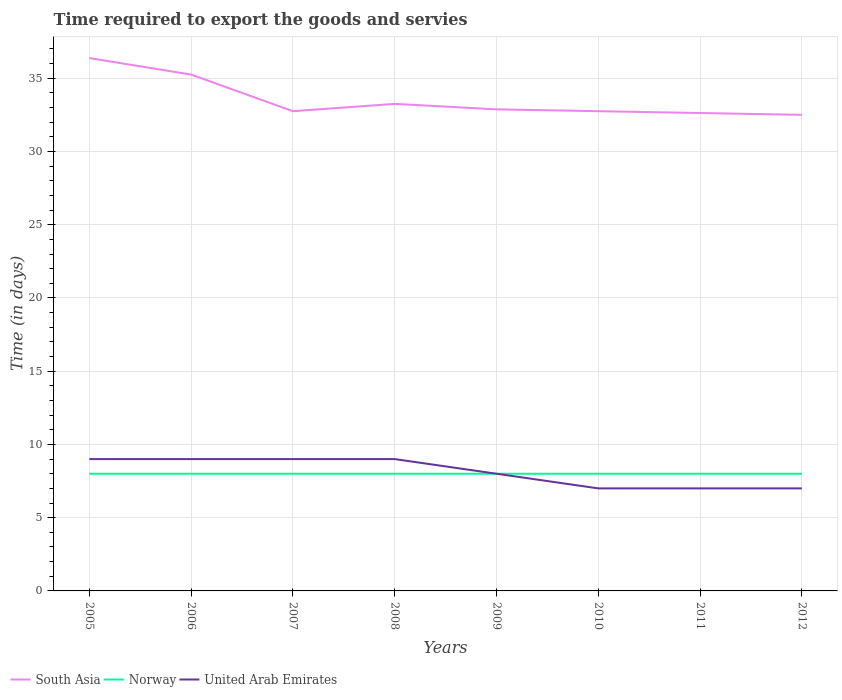How many different coloured lines are there?
Keep it short and to the point. 3. Does the line corresponding to United Arab Emirates intersect with the line corresponding to Norway?
Your response must be concise. Yes. Across all years, what is the maximum number of days required to export the goods and services in Norway?
Your answer should be compact. 8. In which year was the number of days required to export the goods and services in Norway maximum?
Give a very brief answer. 2005. What is the total number of days required to export the goods and services in United Arab Emirates in the graph?
Your answer should be compact. 2. What is the difference between the highest and the lowest number of days required to export the goods and services in Norway?
Your answer should be very brief. 0. Is the number of days required to export the goods and services in Norway strictly greater than the number of days required to export the goods and services in South Asia over the years?
Offer a very short reply. Yes. How many lines are there?
Provide a succinct answer. 3. How many years are there in the graph?
Provide a succinct answer. 8. Where does the legend appear in the graph?
Your response must be concise. Bottom left. How many legend labels are there?
Ensure brevity in your answer.  3. How are the legend labels stacked?
Give a very brief answer. Horizontal. What is the title of the graph?
Offer a terse response. Time required to export the goods and servies. Does "Malawi" appear as one of the legend labels in the graph?
Offer a very short reply. No. What is the label or title of the Y-axis?
Your answer should be compact. Time (in days). What is the Time (in days) of South Asia in 2005?
Ensure brevity in your answer.  36.38. What is the Time (in days) of Norway in 2005?
Keep it short and to the point. 8. What is the Time (in days) in South Asia in 2006?
Keep it short and to the point. 35.25. What is the Time (in days) in Norway in 2006?
Make the answer very short. 8. What is the Time (in days) of United Arab Emirates in 2006?
Ensure brevity in your answer.  9. What is the Time (in days) in South Asia in 2007?
Your response must be concise. 32.75. What is the Time (in days) in Norway in 2007?
Ensure brevity in your answer.  8. What is the Time (in days) of United Arab Emirates in 2007?
Your response must be concise. 9. What is the Time (in days) of South Asia in 2008?
Make the answer very short. 33.25. What is the Time (in days) of United Arab Emirates in 2008?
Offer a terse response. 9. What is the Time (in days) in South Asia in 2009?
Your response must be concise. 32.88. What is the Time (in days) in United Arab Emirates in 2009?
Your answer should be very brief. 8. What is the Time (in days) in South Asia in 2010?
Provide a succinct answer. 32.75. What is the Time (in days) in United Arab Emirates in 2010?
Offer a terse response. 7. What is the Time (in days) of South Asia in 2011?
Provide a succinct answer. 32.62. What is the Time (in days) in Norway in 2011?
Offer a very short reply. 8. What is the Time (in days) in United Arab Emirates in 2011?
Keep it short and to the point. 7. What is the Time (in days) in South Asia in 2012?
Offer a very short reply. 32.5. What is the Time (in days) in Norway in 2012?
Give a very brief answer. 8. What is the Time (in days) of United Arab Emirates in 2012?
Your response must be concise. 7. Across all years, what is the maximum Time (in days) of South Asia?
Keep it short and to the point. 36.38. Across all years, what is the minimum Time (in days) in South Asia?
Make the answer very short. 32.5. Across all years, what is the minimum Time (in days) in Norway?
Provide a short and direct response. 8. What is the total Time (in days) of South Asia in the graph?
Provide a short and direct response. 268.38. What is the total Time (in days) of Norway in the graph?
Your response must be concise. 64. What is the total Time (in days) of United Arab Emirates in the graph?
Your answer should be very brief. 65. What is the difference between the Time (in days) of South Asia in 2005 and that in 2007?
Provide a succinct answer. 3.62. What is the difference between the Time (in days) of Norway in 2005 and that in 2007?
Make the answer very short. 0. What is the difference between the Time (in days) of South Asia in 2005 and that in 2008?
Make the answer very short. 3.12. What is the difference between the Time (in days) of Norway in 2005 and that in 2008?
Make the answer very short. 0. What is the difference between the Time (in days) of South Asia in 2005 and that in 2009?
Offer a very short reply. 3.5. What is the difference between the Time (in days) in United Arab Emirates in 2005 and that in 2009?
Your answer should be very brief. 1. What is the difference between the Time (in days) of South Asia in 2005 and that in 2010?
Your answer should be very brief. 3.62. What is the difference between the Time (in days) of United Arab Emirates in 2005 and that in 2010?
Your answer should be very brief. 2. What is the difference between the Time (in days) of South Asia in 2005 and that in 2011?
Your answer should be very brief. 3.75. What is the difference between the Time (in days) of Norway in 2005 and that in 2011?
Ensure brevity in your answer.  0. What is the difference between the Time (in days) of South Asia in 2005 and that in 2012?
Provide a succinct answer. 3.88. What is the difference between the Time (in days) of Norway in 2005 and that in 2012?
Give a very brief answer. 0. What is the difference between the Time (in days) in United Arab Emirates in 2005 and that in 2012?
Your answer should be very brief. 2. What is the difference between the Time (in days) in Norway in 2006 and that in 2007?
Offer a very short reply. 0. What is the difference between the Time (in days) in United Arab Emirates in 2006 and that in 2007?
Provide a succinct answer. 0. What is the difference between the Time (in days) in United Arab Emirates in 2006 and that in 2008?
Offer a terse response. 0. What is the difference between the Time (in days) in South Asia in 2006 and that in 2009?
Provide a succinct answer. 2.38. What is the difference between the Time (in days) of Norway in 2006 and that in 2009?
Ensure brevity in your answer.  0. What is the difference between the Time (in days) in South Asia in 2006 and that in 2010?
Make the answer very short. 2.5. What is the difference between the Time (in days) in Norway in 2006 and that in 2010?
Provide a succinct answer. 0. What is the difference between the Time (in days) of South Asia in 2006 and that in 2011?
Keep it short and to the point. 2.62. What is the difference between the Time (in days) in Norway in 2006 and that in 2011?
Your answer should be very brief. 0. What is the difference between the Time (in days) of South Asia in 2006 and that in 2012?
Your answer should be compact. 2.75. What is the difference between the Time (in days) of United Arab Emirates in 2006 and that in 2012?
Give a very brief answer. 2. What is the difference between the Time (in days) in South Asia in 2007 and that in 2008?
Your response must be concise. -0.5. What is the difference between the Time (in days) in Norway in 2007 and that in 2008?
Keep it short and to the point. 0. What is the difference between the Time (in days) of United Arab Emirates in 2007 and that in 2008?
Offer a terse response. 0. What is the difference between the Time (in days) in South Asia in 2007 and that in 2009?
Ensure brevity in your answer.  -0.12. What is the difference between the Time (in days) in United Arab Emirates in 2007 and that in 2010?
Your answer should be compact. 2. What is the difference between the Time (in days) in South Asia in 2007 and that in 2011?
Keep it short and to the point. 0.12. What is the difference between the Time (in days) of South Asia in 2007 and that in 2012?
Offer a very short reply. 0.25. What is the difference between the Time (in days) of United Arab Emirates in 2007 and that in 2012?
Your answer should be very brief. 2. What is the difference between the Time (in days) in United Arab Emirates in 2008 and that in 2009?
Make the answer very short. 1. What is the difference between the Time (in days) of United Arab Emirates in 2008 and that in 2010?
Provide a short and direct response. 2. What is the difference between the Time (in days) in South Asia in 2008 and that in 2012?
Ensure brevity in your answer.  0.75. What is the difference between the Time (in days) in South Asia in 2009 and that in 2011?
Your answer should be very brief. 0.25. What is the difference between the Time (in days) of Norway in 2009 and that in 2011?
Offer a very short reply. 0. What is the difference between the Time (in days) of United Arab Emirates in 2009 and that in 2011?
Your answer should be compact. 1. What is the difference between the Time (in days) of Norway in 2009 and that in 2012?
Provide a succinct answer. 0. What is the difference between the Time (in days) in Norway in 2010 and that in 2011?
Provide a short and direct response. 0. What is the difference between the Time (in days) in United Arab Emirates in 2010 and that in 2011?
Your response must be concise. 0. What is the difference between the Time (in days) in South Asia in 2010 and that in 2012?
Offer a very short reply. 0.25. What is the difference between the Time (in days) in Norway in 2010 and that in 2012?
Keep it short and to the point. 0. What is the difference between the Time (in days) of South Asia in 2011 and that in 2012?
Offer a terse response. 0.12. What is the difference between the Time (in days) in Norway in 2011 and that in 2012?
Ensure brevity in your answer.  0. What is the difference between the Time (in days) in South Asia in 2005 and the Time (in days) in Norway in 2006?
Make the answer very short. 28.38. What is the difference between the Time (in days) of South Asia in 2005 and the Time (in days) of United Arab Emirates in 2006?
Your answer should be very brief. 27.38. What is the difference between the Time (in days) in South Asia in 2005 and the Time (in days) in Norway in 2007?
Your answer should be compact. 28.38. What is the difference between the Time (in days) of South Asia in 2005 and the Time (in days) of United Arab Emirates in 2007?
Your response must be concise. 27.38. What is the difference between the Time (in days) of South Asia in 2005 and the Time (in days) of Norway in 2008?
Ensure brevity in your answer.  28.38. What is the difference between the Time (in days) of South Asia in 2005 and the Time (in days) of United Arab Emirates in 2008?
Your answer should be compact. 27.38. What is the difference between the Time (in days) in Norway in 2005 and the Time (in days) in United Arab Emirates in 2008?
Provide a succinct answer. -1. What is the difference between the Time (in days) of South Asia in 2005 and the Time (in days) of Norway in 2009?
Your answer should be compact. 28.38. What is the difference between the Time (in days) of South Asia in 2005 and the Time (in days) of United Arab Emirates in 2009?
Provide a succinct answer. 28.38. What is the difference between the Time (in days) of South Asia in 2005 and the Time (in days) of Norway in 2010?
Give a very brief answer. 28.38. What is the difference between the Time (in days) in South Asia in 2005 and the Time (in days) in United Arab Emirates in 2010?
Ensure brevity in your answer.  29.38. What is the difference between the Time (in days) in Norway in 2005 and the Time (in days) in United Arab Emirates in 2010?
Your answer should be compact. 1. What is the difference between the Time (in days) of South Asia in 2005 and the Time (in days) of Norway in 2011?
Provide a succinct answer. 28.38. What is the difference between the Time (in days) of South Asia in 2005 and the Time (in days) of United Arab Emirates in 2011?
Your answer should be compact. 29.38. What is the difference between the Time (in days) of Norway in 2005 and the Time (in days) of United Arab Emirates in 2011?
Give a very brief answer. 1. What is the difference between the Time (in days) of South Asia in 2005 and the Time (in days) of Norway in 2012?
Your answer should be compact. 28.38. What is the difference between the Time (in days) in South Asia in 2005 and the Time (in days) in United Arab Emirates in 2012?
Offer a very short reply. 29.38. What is the difference between the Time (in days) in Norway in 2005 and the Time (in days) in United Arab Emirates in 2012?
Offer a very short reply. 1. What is the difference between the Time (in days) in South Asia in 2006 and the Time (in days) in Norway in 2007?
Your response must be concise. 27.25. What is the difference between the Time (in days) of South Asia in 2006 and the Time (in days) of United Arab Emirates in 2007?
Ensure brevity in your answer.  26.25. What is the difference between the Time (in days) of South Asia in 2006 and the Time (in days) of Norway in 2008?
Offer a very short reply. 27.25. What is the difference between the Time (in days) of South Asia in 2006 and the Time (in days) of United Arab Emirates in 2008?
Provide a short and direct response. 26.25. What is the difference between the Time (in days) in Norway in 2006 and the Time (in days) in United Arab Emirates in 2008?
Your answer should be compact. -1. What is the difference between the Time (in days) in South Asia in 2006 and the Time (in days) in Norway in 2009?
Make the answer very short. 27.25. What is the difference between the Time (in days) in South Asia in 2006 and the Time (in days) in United Arab Emirates in 2009?
Provide a succinct answer. 27.25. What is the difference between the Time (in days) in South Asia in 2006 and the Time (in days) in Norway in 2010?
Your answer should be very brief. 27.25. What is the difference between the Time (in days) in South Asia in 2006 and the Time (in days) in United Arab Emirates in 2010?
Offer a terse response. 28.25. What is the difference between the Time (in days) of South Asia in 2006 and the Time (in days) of Norway in 2011?
Make the answer very short. 27.25. What is the difference between the Time (in days) of South Asia in 2006 and the Time (in days) of United Arab Emirates in 2011?
Your answer should be compact. 28.25. What is the difference between the Time (in days) in Norway in 2006 and the Time (in days) in United Arab Emirates in 2011?
Your answer should be compact. 1. What is the difference between the Time (in days) of South Asia in 2006 and the Time (in days) of Norway in 2012?
Provide a short and direct response. 27.25. What is the difference between the Time (in days) of South Asia in 2006 and the Time (in days) of United Arab Emirates in 2012?
Your answer should be compact. 28.25. What is the difference between the Time (in days) in Norway in 2006 and the Time (in days) in United Arab Emirates in 2012?
Provide a short and direct response. 1. What is the difference between the Time (in days) in South Asia in 2007 and the Time (in days) in Norway in 2008?
Keep it short and to the point. 24.75. What is the difference between the Time (in days) in South Asia in 2007 and the Time (in days) in United Arab Emirates in 2008?
Your answer should be very brief. 23.75. What is the difference between the Time (in days) of Norway in 2007 and the Time (in days) of United Arab Emirates in 2008?
Your answer should be compact. -1. What is the difference between the Time (in days) of South Asia in 2007 and the Time (in days) of Norway in 2009?
Offer a very short reply. 24.75. What is the difference between the Time (in days) in South Asia in 2007 and the Time (in days) in United Arab Emirates in 2009?
Keep it short and to the point. 24.75. What is the difference between the Time (in days) of South Asia in 2007 and the Time (in days) of Norway in 2010?
Give a very brief answer. 24.75. What is the difference between the Time (in days) in South Asia in 2007 and the Time (in days) in United Arab Emirates in 2010?
Make the answer very short. 25.75. What is the difference between the Time (in days) of Norway in 2007 and the Time (in days) of United Arab Emirates in 2010?
Provide a short and direct response. 1. What is the difference between the Time (in days) of South Asia in 2007 and the Time (in days) of Norway in 2011?
Offer a terse response. 24.75. What is the difference between the Time (in days) in South Asia in 2007 and the Time (in days) in United Arab Emirates in 2011?
Your answer should be compact. 25.75. What is the difference between the Time (in days) of Norway in 2007 and the Time (in days) of United Arab Emirates in 2011?
Give a very brief answer. 1. What is the difference between the Time (in days) of South Asia in 2007 and the Time (in days) of Norway in 2012?
Your answer should be compact. 24.75. What is the difference between the Time (in days) of South Asia in 2007 and the Time (in days) of United Arab Emirates in 2012?
Make the answer very short. 25.75. What is the difference between the Time (in days) of Norway in 2007 and the Time (in days) of United Arab Emirates in 2012?
Offer a terse response. 1. What is the difference between the Time (in days) of South Asia in 2008 and the Time (in days) of Norway in 2009?
Provide a short and direct response. 25.25. What is the difference between the Time (in days) in South Asia in 2008 and the Time (in days) in United Arab Emirates in 2009?
Make the answer very short. 25.25. What is the difference between the Time (in days) in South Asia in 2008 and the Time (in days) in Norway in 2010?
Provide a short and direct response. 25.25. What is the difference between the Time (in days) of South Asia in 2008 and the Time (in days) of United Arab Emirates in 2010?
Ensure brevity in your answer.  26.25. What is the difference between the Time (in days) in Norway in 2008 and the Time (in days) in United Arab Emirates in 2010?
Your answer should be very brief. 1. What is the difference between the Time (in days) in South Asia in 2008 and the Time (in days) in Norway in 2011?
Your answer should be compact. 25.25. What is the difference between the Time (in days) in South Asia in 2008 and the Time (in days) in United Arab Emirates in 2011?
Your answer should be compact. 26.25. What is the difference between the Time (in days) of South Asia in 2008 and the Time (in days) of Norway in 2012?
Your answer should be very brief. 25.25. What is the difference between the Time (in days) in South Asia in 2008 and the Time (in days) in United Arab Emirates in 2012?
Your response must be concise. 26.25. What is the difference between the Time (in days) in Norway in 2008 and the Time (in days) in United Arab Emirates in 2012?
Your response must be concise. 1. What is the difference between the Time (in days) of South Asia in 2009 and the Time (in days) of Norway in 2010?
Give a very brief answer. 24.88. What is the difference between the Time (in days) of South Asia in 2009 and the Time (in days) of United Arab Emirates in 2010?
Your response must be concise. 25.88. What is the difference between the Time (in days) in South Asia in 2009 and the Time (in days) in Norway in 2011?
Give a very brief answer. 24.88. What is the difference between the Time (in days) in South Asia in 2009 and the Time (in days) in United Arab Emirates in 2011?
Offer a terse response. 25.88. What is the difference between the Time (in days) in Norway in 2009 and the Time (in days) in United Arab Emirates in 2011?
Give a very brief answer. 1. What is the difference between the Time (in days) of South Asia in 2009 and the Time (in days) of Norway in 2012?
Keep it short and to the point. 24.88. What is the difference between the Time (in days) of South Asia in 2009 and the Time (in days) of United Arab Emirates in 2012?
Offer a terse response. 25.88. What is the difference between the Time (in days) of South Asia in 2010 and the Time (in days) of Norway in 2011?
Provide a short and direct response. 24.75. What is the difference between the Time (in days) in South Asia in 2010 and the Time (in days) in United Arab Emirates in 2011?
Your answer should be compact. 25.75. What is the difference between the Time (in days) in South Asia in 2010 and the Time (in days) in Norway in 2012?
Provide a short and direct response. 24.75. What is the difference between the Time (in days) of South Asia in 2010 and the Time (in days) of United Arab Emirates in 2012?
Provide a succinct answer. 25.75. What is the difference between the Time (in days) of Norway in 2010 and the Time (in days) of United Arab Emirates in 2012?
Your answer should be very brief. 1. What is the difference between the Time (in days) in South Asia in 2011 and the Time (in days) in Norway in 2012?
Offer a terse response. 24.62. What is the difference between the Time (in days) in South Asia in 2011 and the Time (in days) in United Arab Emirates in 2012?
Provide a succinct answer. 25.62. What is the average Time (in days) in South Asia per year?
Your response must be concise. 33.55. What is the average Time (in days) in Norway per year?
Offer a very short reply. 8. What is the average Time (in days) of United Arab Emirates per year?
Provide a short and direct response. 8.12. In the year 2005, what is the difference between the Time (in days) in South Asia and Time (in days) in Norway?
Your answer should be compact. 28.38. In the year 2005, what is the difference between the Time (in days) of South Asia and Time (in days) of United Arab Emirates?
Ensure brevity in your answer.  27.38. In the year 2006, what is the difference between the Time (in days) of South Asia and Time (in days) of Norway?
Give a very brief answer. 27.25. In the year 2006, what is the difference between the Time (in days) of South Asia and Time (in days) of United Arab Emirates?
Keep it short and to the point. 26.25. In the year 2006, what is the difference between the Time (in days) of Norway and Time (in days) of United Arab Emirates?
Offer a very short reply. -1. In the year 2007, what is the difference between the Time (in days) in South Asia and Time (in days) in Norway?
Keep it short and to the point. 24.75. In the year 2007, what is the difference between the Time (in days) in South Asia and Time (in days) in United Arab Emirates?
Your answer should be compact. 23.75. In the year 2008, what is the difference between the Time (in days) of South Asia and Time (in days) of Norway?
Ensure brevity in your answer.  25.25. In the year 2008, what is the difference between the Time (in days) in South Asia and Time (in days) in United Arab Emirates?
Your answer should be compact. 24.25. In the year 2008, what is the difference between the Time (in days) in Norway and Time (in days) in United Arab Emirates?
Your answer should be very brief. -1. In the year 2009, what is the difference between the Time (in days) in South Asia and Time (in days) in Norway?
Your response must be concise. 24.88. In the year 2009, what is the difference between the Time (in days) of South Asia and Time (in days) of United Arab Emirates?
Your answer should be compact. 24.88. In the year 2009, what is the difference between the Time (in days) in Norway and Time (in days) in United Arab Emirates?
Provide a short and direct response. 0. In the year 2010, what is the difference between the Time (in days) in South Asia and Time (in days) in Norway?
Your answer should be compact. 24.75. In the year 2010, what is the difference between the Time (in days) in South Asia and Time (in days) in United Arab Emirates?
Keep it short and to the point. 25.75. In the year 2011, what is the difference between the Time (in days) of South Asia and Time (in days) of Norway?
Make the answer very short. 24.62. In the year 2011, what is the difference between the Time (in days) in South Asia and Time (in days) in United Arab Emirates?
Make the answer very short. 25.62. In the year 2011, what is the difference between the Time (in days) in Norway and Time (in days) in United Arab Emirates?
Give a very brief answer. 1. In the year 2012, what is the difference between the Time (in days) in South Asia and Time (in days) in Norway?
Provide a succinct answer. 24.5. In the year 2012, what is the difference between the Time (in days) in South Asia and Time (in days) in United Arab Emirates?
Your answer should be very brief. 25.5. What is the ratio of the Time (in days) in South Asia in 2005 to that in 2006?
Give a very brief answer. 1.03. What is the ratio of the Time (in days) in Norway in 2005 to that in 2006?
Keep it short and to the point. 1. What is the ratio of the Time (in days) in South Asia in 2005 to that in 2007?
Keep it short and to the point. 1.11. What is the ratio of the Time (in days) of Norway in 2005 to that in 2007?
Keep it short and to the point. 1. What is the ratio of the Time (in days) in South Asia in 2005 to that in 2008?
Provide a short and direct response. 1.09. What is the ratio of the Time (in days) in Norway in 2005 to that in 2008?
Give a very brief answer. 1. What is the ratio of the Time (in days) of South Asia in 2005 to that in 2009?
Keep it short and to the point. 1.11. What is the ratio of the Time (in days) in South Asia in 2005 to that in 2010?
Give a very brief answer. 1.11. What is the ratio of the Time (in days) of Norway in 2005 to that in 2010?
Provide a short and direct response. 1. What is the ratio of the Time (in days) in United Arab Emirates in 2005 to that in 2010?
Provide a short and direct response. 1.29. What is the ratio of the Time (in days) of South Asia in 2005 to that in 2011?
Provide a succinct answer. 1.11. What is the ratio of the Time (in days) of Norway in 2005 to that in 2011?
Your answer should be compact. 1. What is the ratio of the Time (in days) of United Arab Emirates in 2005 to that in 2011?
Your answer should be compact. 1.29. What is the ratio of the Time (in days) of South Asia in 2005 to that in 2012?
Your response must be concise. 1.12. What is the ratio of the Time (in days) in South Asia in 2006 to that in 2007?
Offer a terse response. 1.08. What is the ratio of the Time (in days) of United Arab Emirates in 2006 to that in 2007?
Provide a succinct answer. 1. What is the ratio of the Time (in days) of South Asia in 2006 to that in 2008?
Make the answer very short. 1.06. What is the ratio of the Time (in days) in Norway in 2006 to that in 2008?
Ensure brevity in your answer.  1. What is the ratio of the Time (in days) in United Arab Emirates in 2006 to that in 2008?
Your answer should be compact. 1. What is the ratio of the Time (in days) in South Asia in 2006 to that in 2009?
Offer a very short reply. 1.07. What is the ratio of the Time (in days) of South Asia in 2006 to that in 2010?
Provide a short and direct response. 1.08. What is the ratio of the Time (in days) in South Asia in 2006 to that in 2011?
Give a very brief answer. 1.08. What is the ratio of the Time (in days) in South Asia in 2006 to that in 2012?
Provide a short and direct response. 1.08. What is the ratio of the Time (in days) in United Arab Emirates in 2006 to that in 2012?
Your answer should be compact. 1.29. What is the ratio of the Time (in days) in Norway in 2007 to that in 2008?
Give a very brief answer. 1. What is the ratio of the Time (in days) of South Asia in 2007 to that in 2009?
Give a very brief answer. 1. What is the ratio of the Time (in days) of Norway in 2007 to that in 2009?
Your answer should be compact. 1. What is the ratio of the Time (in days) in United Arab Emirates in 2007 to that in 2009?
Provide a succinct answer. 1.12. What is the ratio of the Time (in days) of South Asia in 2007 to that in 2010?
Keep it short and to the point. 1. What is the ratio of the Time (in days) of South Asia in 2007 to that in 2011?
Offer a terse response. 1. What is the ratio of the Time (in days) in Norway in 2007 to that in 2011?
Offer a very short reply. 1. What is the ratio of the Time (in days) of United Arab Emirates in 2007 to that in 2011?
Offer a very short reply. 1.29. What is the ratio of the Time (in days) in South Asia in 2007 to that in 2012?
Provide a short and direct response. 1.01. What is the ratio of the Time (in days) of Norway in 2007 to that in 2012?
Offer a very short reply. 1. What is the ratio of the Time (in days) of South Asia in 2008 to that in 2009?
Your answer should be compact. 1.01. What is the ratio of the Time (in days) in Norway in 2008 to that in 2009?
Your response must be concise. 1. What is the ratio of the Time (in days) in United Arab Emirates in 2008 to that in 2009?
Make the answer very short. 1.12. What is the ratio of the Time (in days) of South Asia in 2008 to that in 2010?
Offer a very short reply. 1.02. What is the ratio of the Time (in days) of Norway in 2008 to that in 2010?
Keep it short and to the point. 1. What is the ratio of the Time (in days) in United Arab Emirates in 2008 to that in 2010?
Make the answer very short. 1.29. What is the ratio of the Time (in days) in South Asia in 2008 to that in 2011?
Your answer should be very brief. 1.02. What is the ratio of the Time (in days) in Norway in 2008 to that in 2011?
Give a very brief answer. 1. What is the ratio of the Time (in days) of South Asia in 2008 to that in 2012?
Make the answer very short. 1.02. What is the ratio of the Time (in days) of Norway in 2008 to that in 2012?
Offer a very short reply. 1. What is the ratio of the Time (in days) in United Arab Emirates in 2009 to that in 2010?
Make the answer very short. 1.14. What is the ratio of the Time (in days) in South Asia in 2009 to that in 2011?
Provide a succinct answer. 1.01. What is the ratio of the Time (in days) in Norway in 2009 to that in 2011?
Your answer should be very brief. 1. What is the ratio of the Time (in days) in United Arab Emirates in 2009 to that in 2011?
Give a very brief answer. 1.14. What is the ratio of the Time (in days) of South Asia in 2009 to that in 2012?
Your answer should be very brief. 1.01. What is the ratio of the Time (in days) in United Arab Emirates in 2010 to that in 2011?
Your answer should be very brief. 1. What is the ratio of the Time (in days) of South Asia in 2010 to that in 2012?
Make the answer very short. 1.01. What is the ratio of the Time (in days) in United Arab Emirates in 2010 to that in 2012?
Provide a short and direct response. 1. What is the difference between the highest and the lowest Time (in days) of South Asia?
Provide a succinct answer. 3.88. What is the difference between the highest and the lowest Time (in days) in Norway?
Make the answer very short. 0. What is the difference between the highest and the lowest Time (in days) in United Arab Emirates?
Provide a succinct answer. 2. 